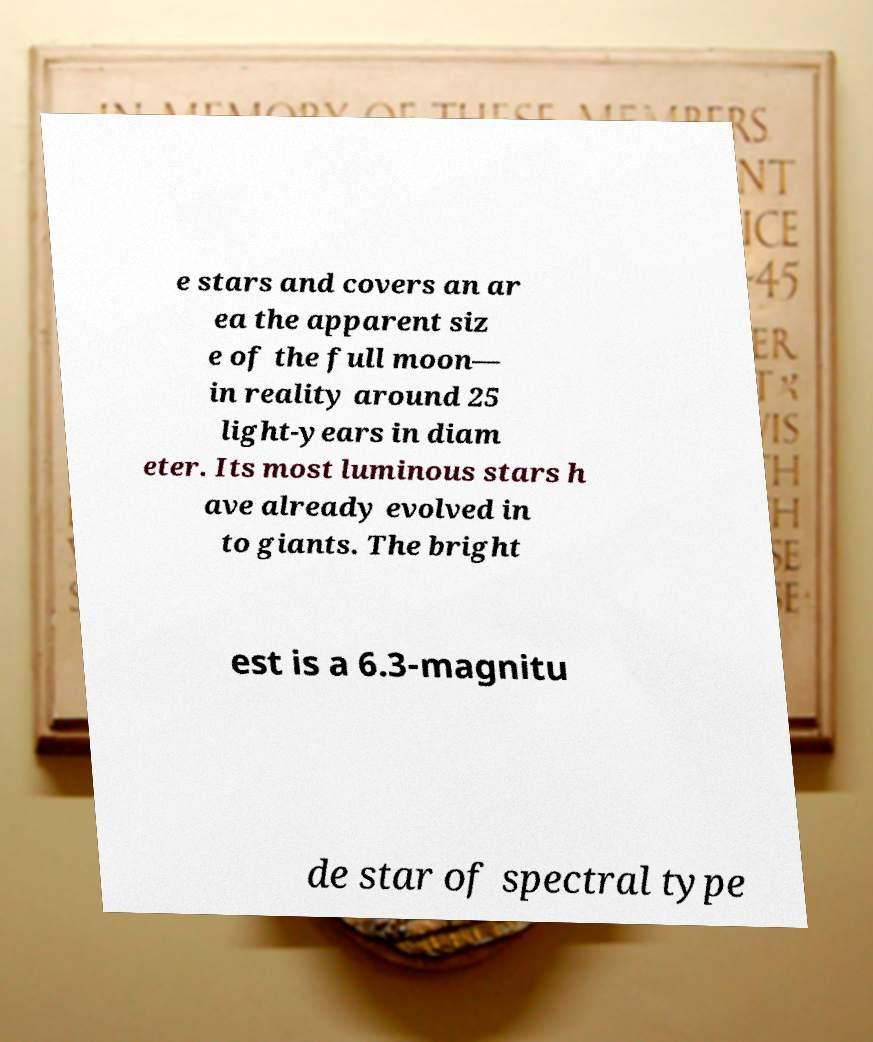Can you read and provide the text displayed in the image?This photo seems to have some interesting text. Can you extract and type it out for me? e stars and covers an ar ea the apparent siz e of the full moon— in reality around 25 light-years in diam eter. Its most luminous stars h ave already evolved in to giants. The bright est is a 6.3-magnitu de star of spectral type 